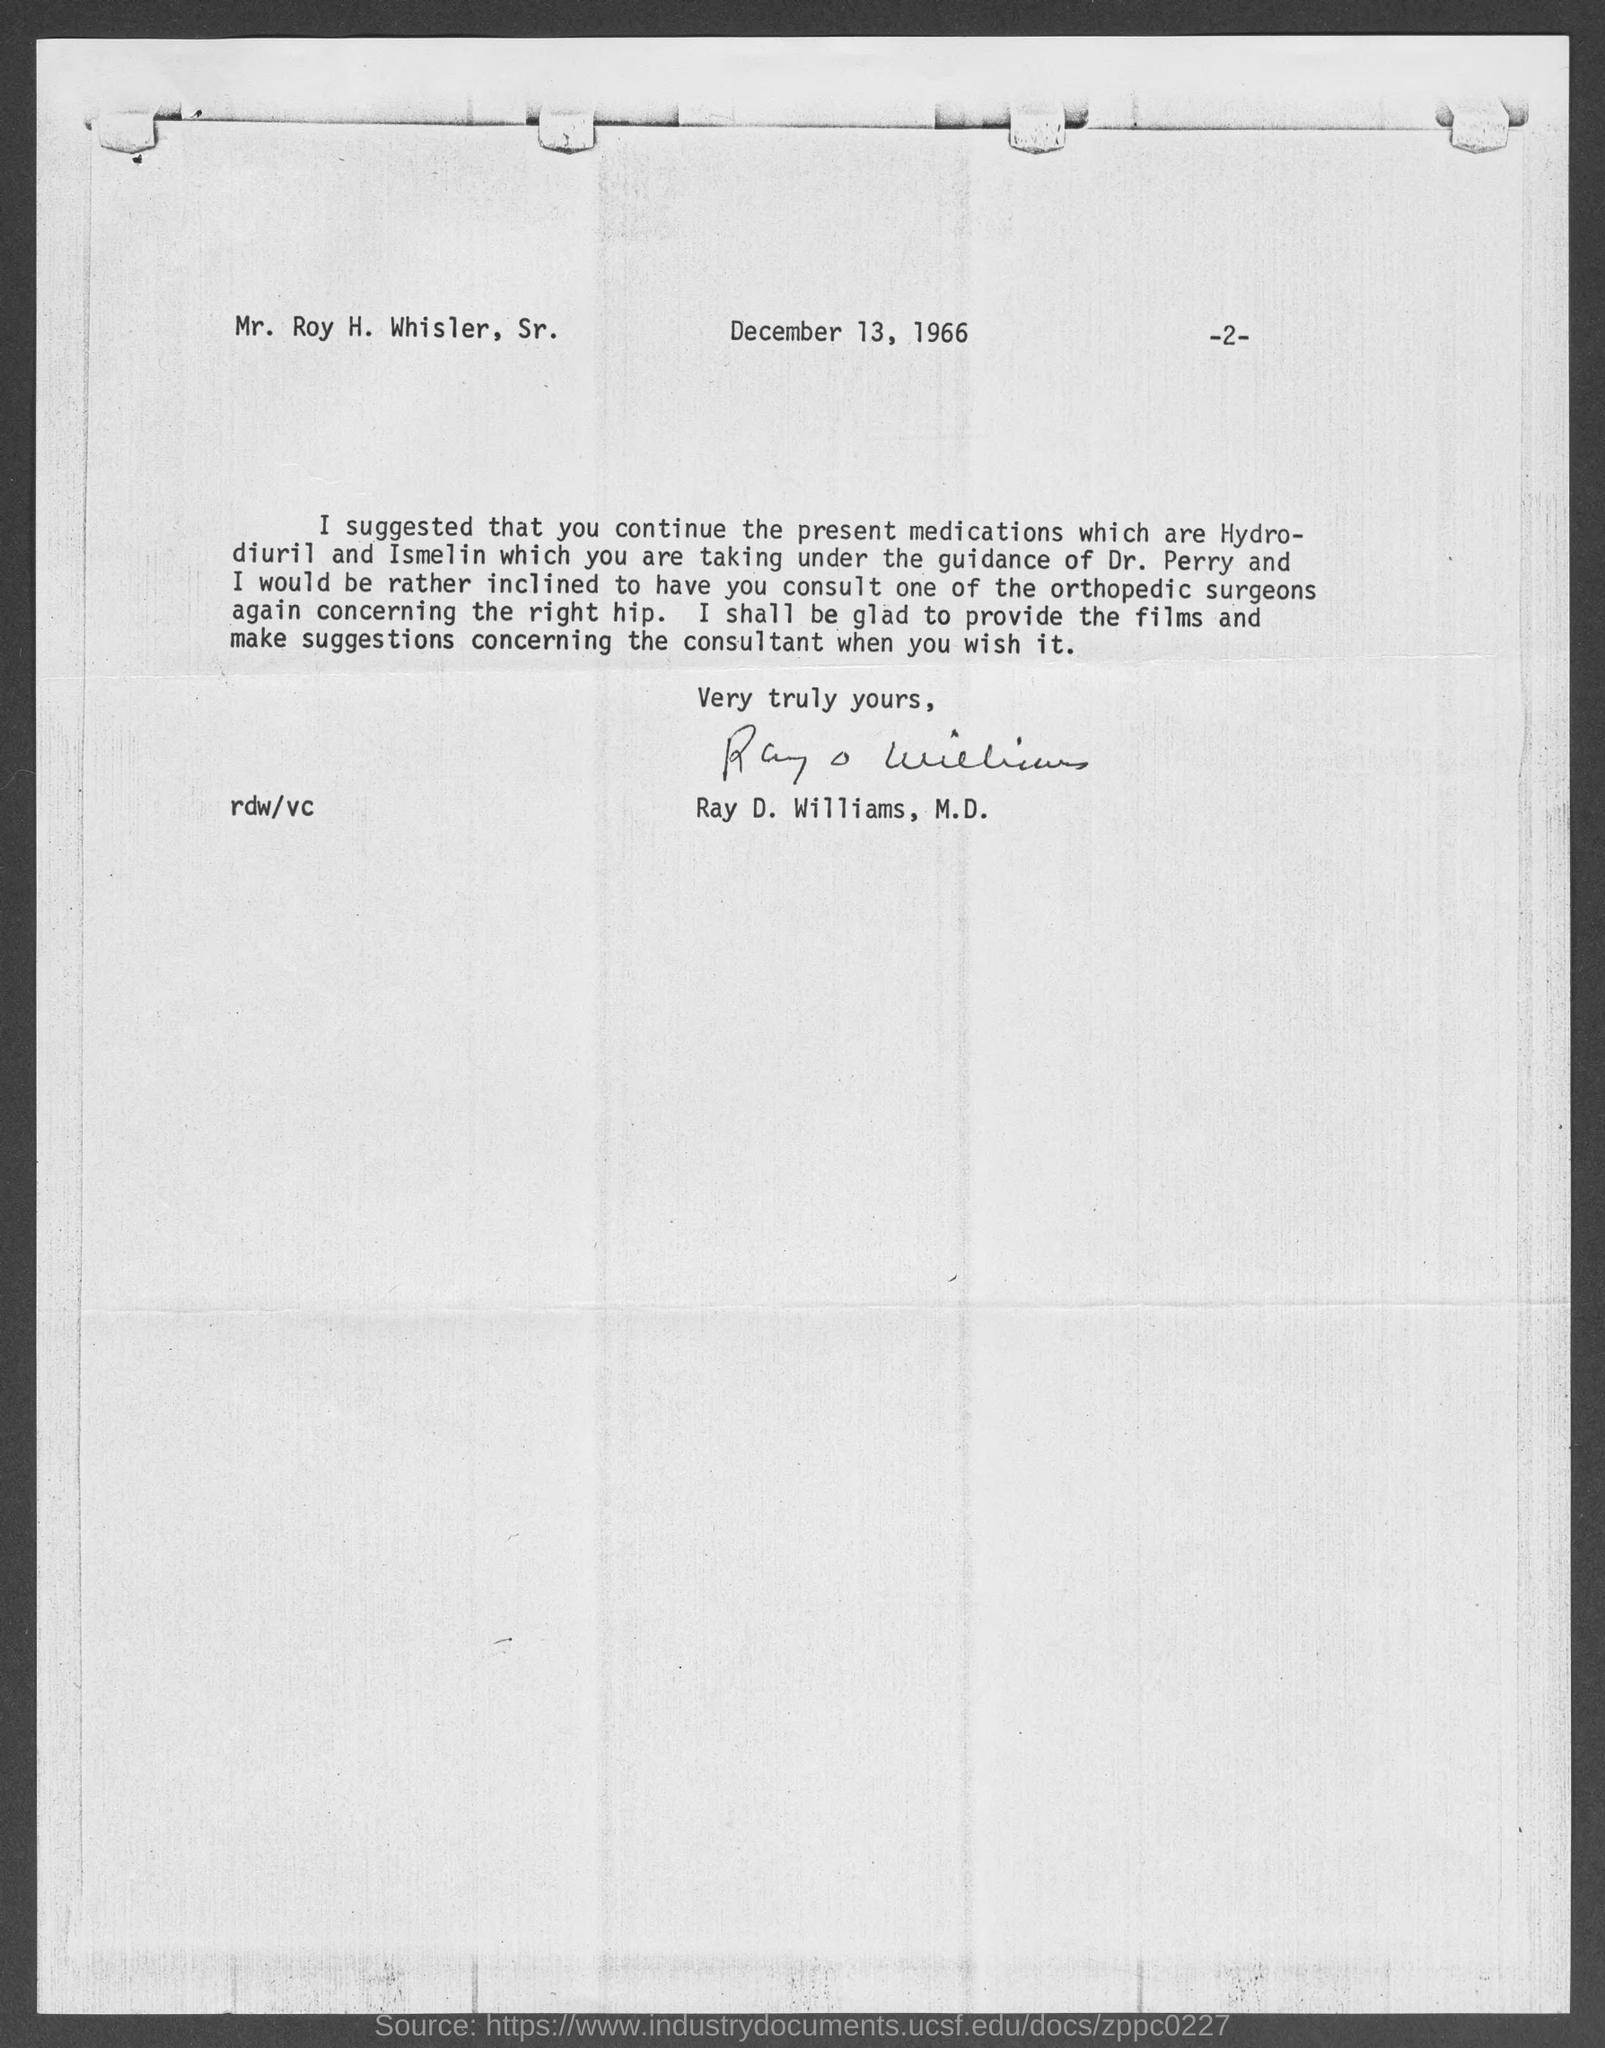Specify some key components in this picture. Ray D. Williams, M.D., is the author of the memorandum. The memorandum was dated on December 13, 1966. 